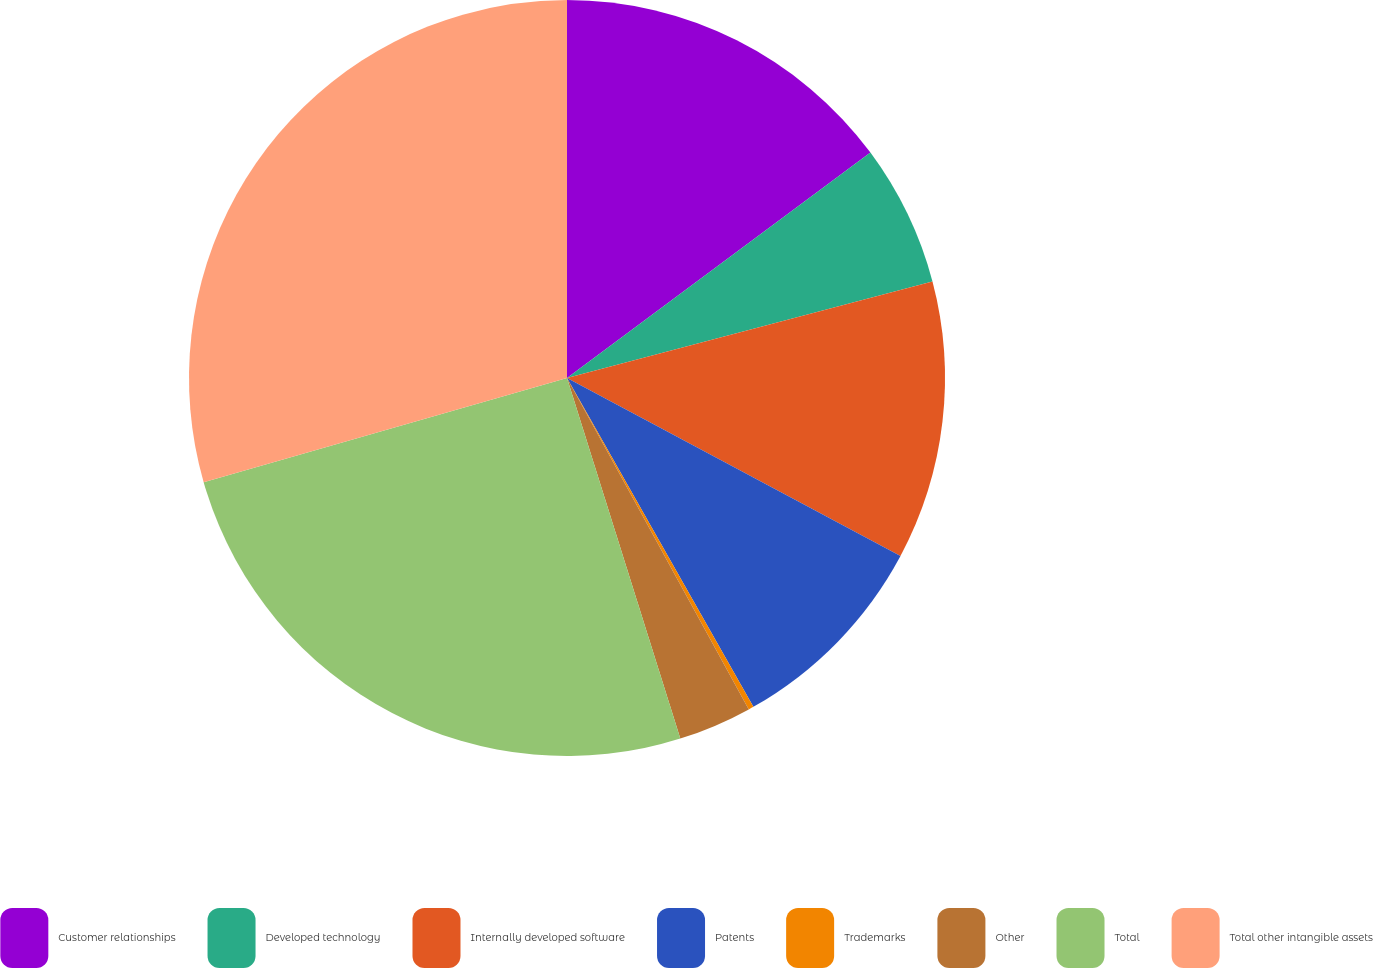Convert chart. <chart><loc_0><loc_0><loc_500><loc_500><pie_chart><fcel>Customer relationships<fcel>Developed technology<fcel>Internally developed software<fcel>Patents<fcel>Trademarks<fcel>Other<fcel>Total<fcel>Total other intangible assets<nl><fcel>14.83%<fcel>6.06%<fcel>11.91%<fcel>8.99%<fcel>0.22%<fcel>3.14%<fcel>25.4%<fcel>29.44%<nl></chart> 